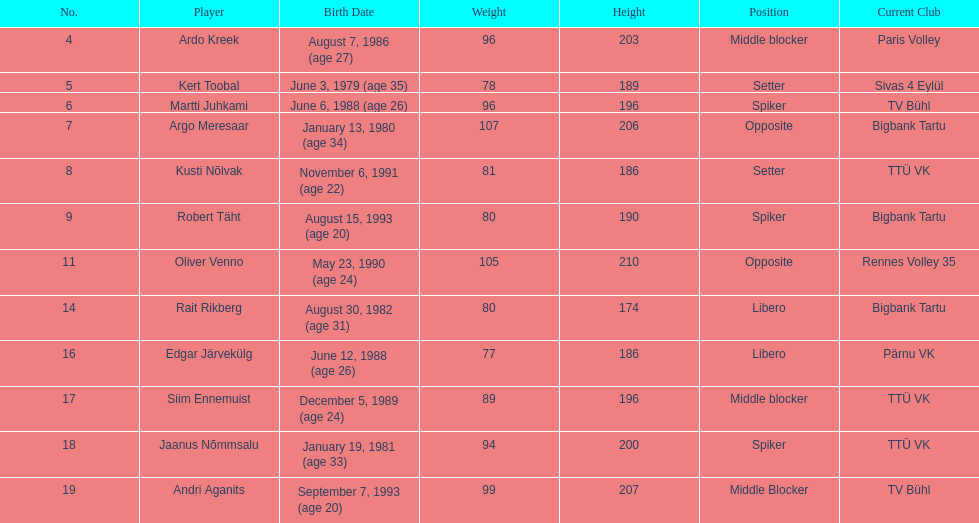On the men's national volleyball team of estonia, which player is the tallest? Oliver Venno. 